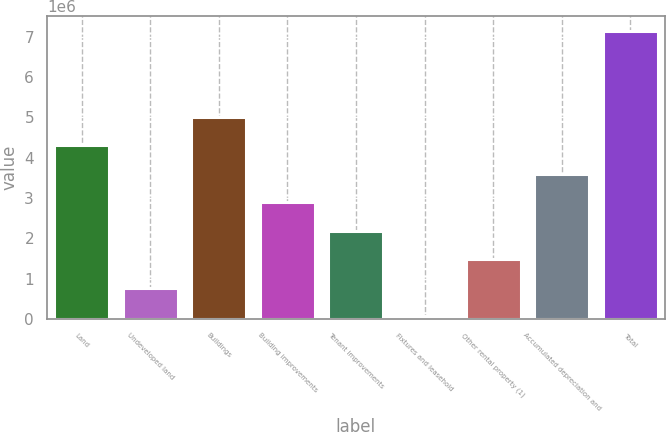<chart> <loc_0><loc_0><loc_500><loc_500><bar_chart><fcel>Land<fcel>Undeveloped land<fcel>Buildings<fcel>Building improvements<fcel>Tenant improvements<fcel>Fixtures and leasehold<fcel>Other rental property (1)<fcel>Accumulated depreciation and<fcel>Total<nl><fcel>4.31251e+06<fcel>769598<fcel>5.0211e+06<fcel>2.89535e+06<fcel>2.18676e+06<fcel>61015<fcel>1.47818e+06<fcel>3.60393e+06<fcel>7.14684e+06<nl></chart> 